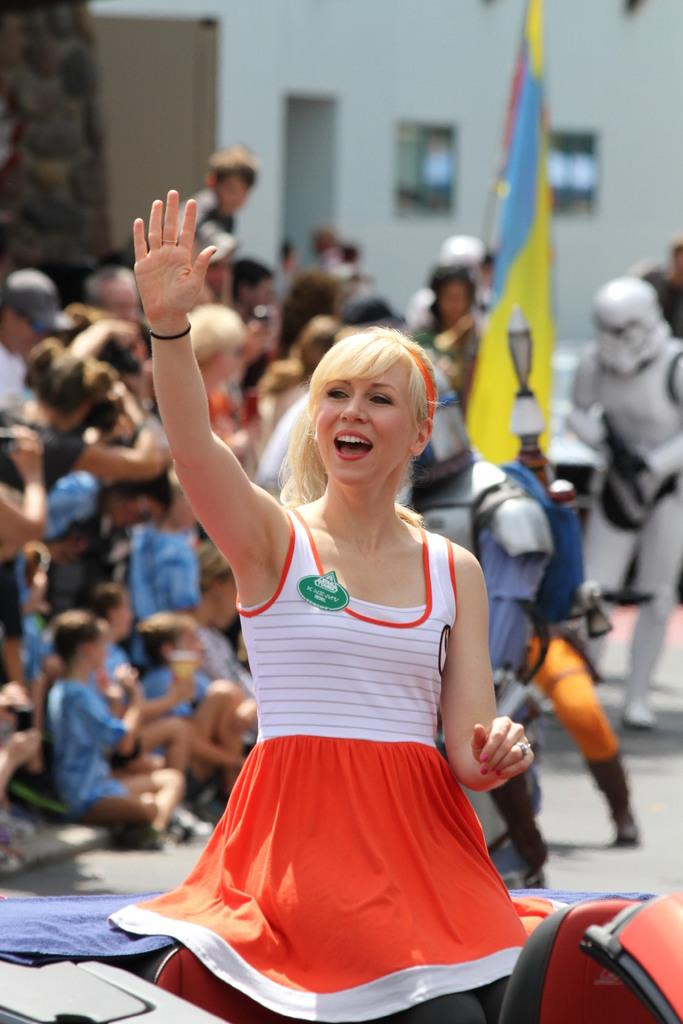Who is present in the image? There is a woman in the image. What is the woman doing in the image? The woman is smiling in the image. Can you describe the background of the image? There is a group of people in the background of the image. What type of quarter is being used to look at the kettle in the image? There is no quarter, look, or kettle present in the image. 